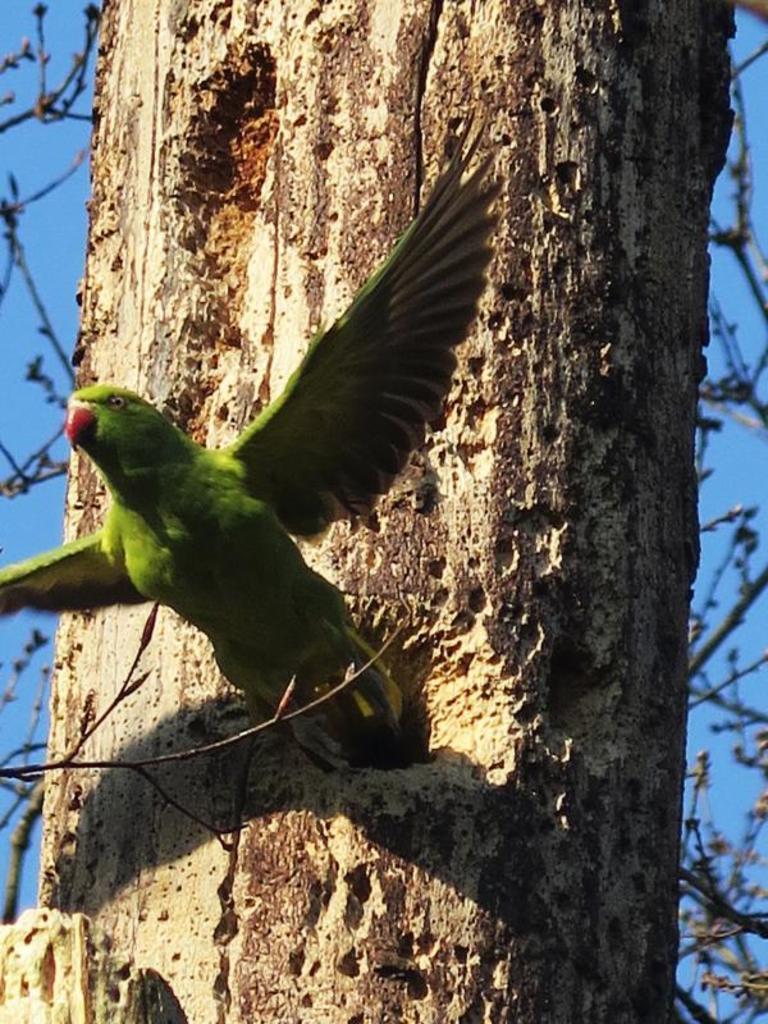Where was the picture taken? The picture was clicked outside. What animal can be seen in the image? There is a parrot in the image. What is the parrot doing in the image? The parrot appears to be flying in the air. What can be seen in the background of the image? There is a sky, a tree trunk, and tree stems visible in the background of the image. How many rabbits can be seen hopping on the twig in the image? There are no rabbits or twigs present in the image. What sound do the bells make in the image? There are no bells present in the image. 